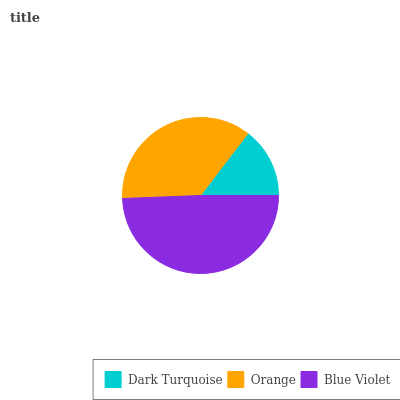Is Dark Turquoise the minimum?
Answer yes or no. Yes. Is Blue Violet the maximum?
Answer yes or no. Yes. Is Orange the minimum?
Answer yes or no. No. Is Orange the maximum?
Answer yes or no. No. Is Orange greater than Dark Turquoise?
Answer yes or no. Yes. Is Dark Turquoise less than Orange?
Answer yes or no. Yes. Is Dark Turquoise greater than Orange?
Answer yes or no. No. Is Orange less than Dark Turquoise?
Answer yes or no. No. Is Orange the high median?
Answer yes or no. Yes. Is Orange the low median?
Answer yes or no. Yes. Is Dark Turquoise the high median?
Answer yes or no. No. Is Dark Turquoise the low median?
Answer yes or no. No. 